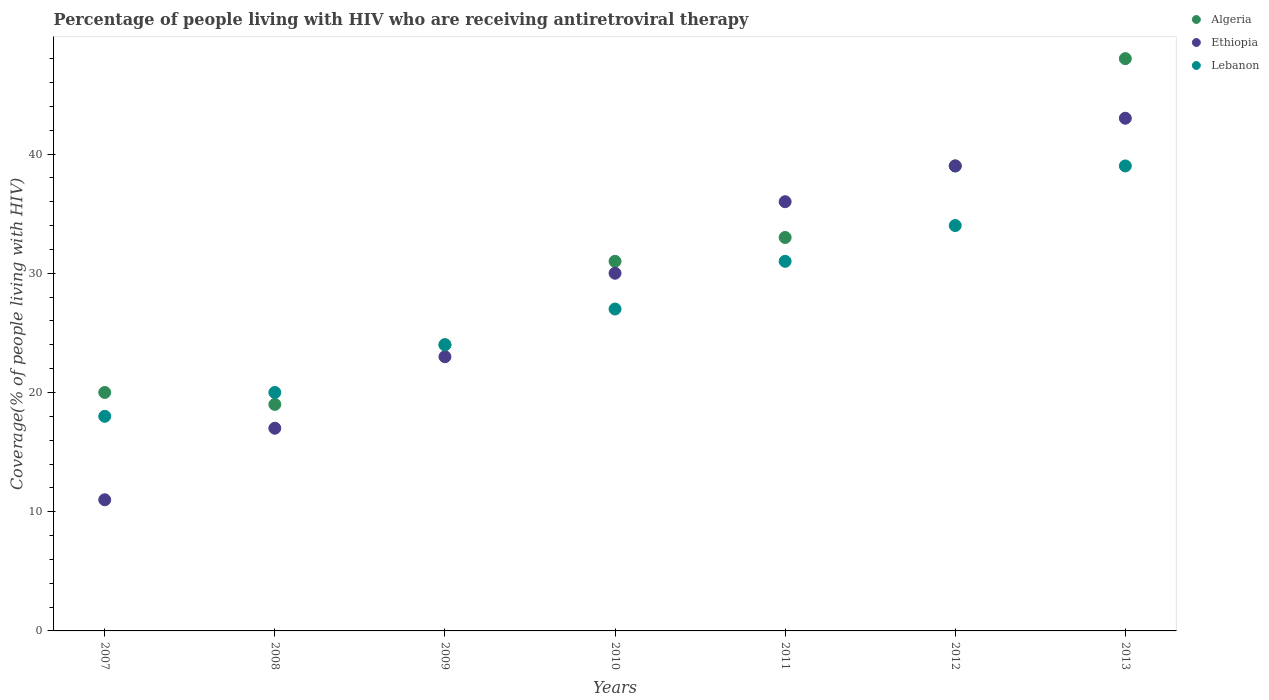How many different coloured dotlines are there?
Your answer should be very brief. 3. Is the number of dotlines equal to the number of legend labels?
Give a very brief answer. Yes. What is the percentage of the HIV infected people who are receiving antiretroviral therapy in Ethiopia in 2009?
Give a very brief answer. 23. Across all years, what is the maximum percentage of the HIV infected people who are receiving antiretroviral therapy in Lebanon?
Your answer should be compact. 39. Across all years, what is the minimum percentage of the HIV infected people who are receiving antiretroviral therapy in Ethiopia?
Ensure brevity in your answer.  11. In which year was the percentage of the HIV infected people who are receiving antiretroviral therapy in Lebanon maximum?
Ensure brevity in your answer.  2013. In which year was the percentage of the HIV infected people who are receiving antiretroviral therapy in Ethiopia minimum?
Make the answer very short. 2007. What is the total percentage of the HIV infected people who are receiving antiretroviral therapy in Algeria in the graph?
Provide a short and direct response. 214. What is the difference between the percentage of the HIV infected people who are receiving antiretroviral therapy in Ethiopia in 2009 and that in 2013?
Provide a short and direct response. -20. What is the difference between the percentage of the HIV infected people who are receiving antiretroviral therapy in Lebanon in 2011 and the percentage of the HIV infected people who are receiving antiretroviral therapy in Ethiopia in 2007?
Provide a short and direct response. 20. What is the average percentage of the HIV infected people who are receiving antiretroviral therapy in Algeria per year?
Your answer should be compact. 30.57. In the year 2010, what is the difference between the percentage of the HIV infected people who are receiving antiretroviral therapy in Lebanon and percentage of the HIV infected people who are receiving antiretroviral therapy in Algeria?
Provide a short and direct response. -4. In how many years, is the percentage of the HIV infected people who are receiving antiretroviral therapy in Ethiopia greater than 28 %?
Give a very brief answer. 4. What is the ratio of the percentage of the HIV infected people who are receiving antiretroviral therapy in Lebanon in 2008 to that in 2013?
Provide a succinct answer. 0.51. Is the percentage of the HIV infected people who are receiving antiretroviral therapy in Lebanon in 2009 less than that in 2011?
Ensure brevity in your answer.  Yes. What is the difference between the highest and the lowest percentage of the HIV infected people who are receiving antiretroviral therapy in Ethiopia?
Offer a terse response. 32. Does the percentage of the HIV infected people who are receiving antiretroviral therapy in Lebanon monotonically increase over the years?
Ensure brevity in your answer.  Yes. How many dotlines are there?
Your answer should be compact. 3. Does the graph contain any zero values?
Offer a very short reply. No. Does the graph contain grids?
Provide a succinct answer. No. Where does the legend appear in the graph?
Ensure brevity in your answer.  Top right. What is the title of the graph?
Your answer should be compact. Percentage of people living with HIV who are receiving antiretroviral therapy. Does "Netherlands" appear as one of the legend labels in the graph?
Make the answer very short. No. What is the label or title of the Y-axis?
Offer a very short reply. Coverage(% of people living with HIV). What is the Coverage(% of people living with HIV) in Algeria in 2008?
Ensure brevity in your answer.  19. What is the Coverage(% of people living with HIV) in Ethiopia in 2009?
Give a very brief answer. 23. What is the Coverage(% of people living with HIV) in Lebanon in 2009?
Ensure brevity in your answer.  24. What is the Coverage(% of people living with HIV) in Algeria in 2010?
Provide a succinct answer. 31. What is the Coverage(% of people living with HIV) in Lebanon in 2010?
Give a very brief answer. 27. What is the Coverage(% of people living with HIV) in Algeria in 2011?
Your response must be concise. 33. What is the Coverage(% of people living with HIV) of Ethiopia in 2011?
Provide a short and direct response. 36. What is the Coverage(% of people living with HIV) of Ethiopia in 2012?
Give a very brief answer. 39. What is the Coverage(% of people living with HIV) in Lebanon in 2012?
Keep it short and to the point. 34. What is the Coverage(% of people living with HIV) of Ethiopia in 2013?
Offer a very short reply. 43. What is the Coverage(% of people living with HIV) of Lebanon in 2013?
Make the answer very short. 39. Across all years, what is the maximum Coverage(% of people living with HIV) in Ethiopia?
Provide a short and direct response. 43. Across all years, what is the maximum Coverage(% of people living with HIV) in Lebanon?
Offer a terse response. 39. Across all years, what is the minimum Coverage(% of people living with HIV) of Algeria?
Ensure brevity in your answer.  19. Across all years, what is the minimum Coverage(% of people living with HIV) in Lebanon?
Give a very brief answer. 18. What is the total Coverage(% of people living with HIV) of Algeria in the graph?
Provide a short and direct response. 214. What is the total Coverage(% of people living with HIV) of Ethiopia in the graph?
Keep it short and to the point. 199. What is the total Coverage(% of people living with HIV) in Lebanon in the graph?
Provide a short and direct response. 193. What is the difference between the Coverage(% of people living with HIV) in Lebanon in 2007 and that in 2008?
Offer a very short reply. -2. What is the difference between the Coverage(% of people living with HIV) in Lebanon in 2007 and that in 2010?
Offer a terse response. -9. What is the difference between the Coverage(% of people living with HIV) in Algeria in 2007 and that in 2011?
Your answer should be compact. -13. What is the difference between the Coverage(% of people living with HIV) in Lebanon in 2007 and that in 2011?
Your answer should be compact. -13. What is the difference between the Coverage(% of people living with HIV) in Algeria in 2007 and that in 2012?
Offer a very short reply. -19. What is the difference between the Coverage(% of people living with HIV) in Ethiopia in 2007 and that in 2012?
Offer a very short reply. -28. What is the difference between the Coverage(% of people living with HIV) in Ethiopia in 2007 and that in 2013?
Your answer should be very brief. -32. What is the difference between the Coverage(% of people living with HIV) in Algeria in 2008 and that in 2009?
Ensure brevity in your answer.  -5. What is the difference between the Coverage(% of people living with HIV) in Lebanon in 2008 and that in 2009?
Give a very brief answer. -4. What is the difference between the Coverage(% of people living with HIV) in Algeria in 2008 and that in 2010?
Offer a very short reply. -12. What is the difference between the Coverage(% of people living with HIV) of Lebanon in 2008 and that in 2010?
Your answer should be very brief. -7. What is the difference between the Coverage(% of people living with HIV) in Ethiopia in 2008 and that in 2011?
Offer a very short reply. -19. What is the difference between the Coverage(% of people living with HIV) of Algeria in 2008 and that in 2012?
Offer a very short reply. -20. What is the difference between the Coverage(% of people living with HIV) of Lebanon in 2008 and that in 2012?
Give a very brief answer. -14. What is the difference between the Coverage(% of people living with HIV) of Ethiopia in 2008 and that in 2013?
Your answer should be very brief. -26. What is the difference between the Coverage(% of people living with HIV) of Algeria in 2009 and that in 2010?
Make the answer very short. -7. What is the difference between the Coverage(% of people living with HIV) in Algeria in 2009 and that in 2011?
Offer a very short reply. -9. What is the difference between the Coverage(% of people living with HIV) of Lebanon in 2009 and that in 2011?
Your answer should be compact. -7. What is the difference between the Coverage(% of people living with HIV) in Algeria in 2009 and that in 2012?
Your answer should be compact. -15. What is the difference between the Coverage(% of people living with HIV) in Ethiopia in 2009 and that in 2012?
Offer a terse response. -16. What is the difference between the Coverage(% of people living with HIV) in Ethiopia in 2009 and that in 2013?
Your answer should be very brief. -20. What is the difference between the Coverage(% of people living with HIV) in Ethiopia in 2010 and that in 2011?
Provide a succinct answer. -6. What is the difference between the Coverage(% of people living with HIV) in Algeria in 2010 and that in 2012?
Ensure brevity in your answer.  -8. What is the difference between the Coverage(% of people living with HIV) in Ethiopia in 2010 and that in 2012?
Your answer should be compact. -9. What is the difference between the Coverage(% of people living with HIV) in Algeria in 2010 and that in 2013?
Offer a terse response. -17. What is the difference between the Coverage(% of people living with HIV) in Lebanon in 2010 and that in 2013?
Your response must be concise. -12. What is the difference between the Coverage(% of people living with HIV) of Ethiopia in 2011 and that in 2012?
Your response must be concise. -3. What is the difference between the Coverage(% of people living with HIV) of Lebanon in 2011 and that in 2012?
Make the answer very short. -3. What is the difference between the Coverage(% of people living with HIV) in Lebanon in 2012 and that in 2013?
Ensure brevity in your answer.  -5. What is the difference between the Coverage(% of people living with HIV) of Algeria in 2007 and the Coverage(% of people living with HIV) of Lebanon in 2009?
Provide a short and direct response. -4. What is the difference between the Coverage(% of people living with HIV) of Ethiopia in 2007 and the Coverage(% of people living with HIV) of Lebanon in 2009?
Provide a succinct answer. -13. What is the difference between the Coverage(% of people living with HIV) of Algeria in 2007 and the Coverage(% of people living with HIV) of Lebanon in 2011?
Make the answer very short. -11. What is the difference between the Coverage(% of people living with HIV) in Ethiopia in 2007 and the Coverage(% of people living with HIV) in Lebanon in 2011?
Offer a very short reply. -20. What is the difference between the Coverage(% of people living with HIV) of Ethiopia in 2007 and the Coverage(% of people living with HIV) of Lebanon in 2012?
Offer a very short reply. -23. What is the difference between the Coverage(% of people living with HIV) of Algeria in 2007 and the Coverage(% of people living with HIV) of Ethiopia in 2013?
Your response must be concise. -23. What is the difference between the Coverage(% of people living with HIV) of Algeria in 2008 and the Coverage(% of people living with HIV) of Ethiopia in 2009?
Your answer should be very brief. -4. What is the difference between the Coverage(% of people living with HIV) of Algeria in 2008 and the Coverage(% of people living with HIV) of Ethiopia in 2011?
Your answer should be very brief. -17. What is the difference between the Coverage(% of people living with HIV) of Ethiopia in 2008 and the Coverage(% of people living with HIV) of Lebanon in 2012?
Your answer should be compact. -17. What is the difference between the Coverage(% of people living with HIV) of Ethiopia in 2009 and the Coverage(% of people living with HIV) of Lebanon in 2010?
Keep it short and to the point. -4. What is the difference between the Coverage(% of people living with HIV) in Algeria in 2009 and the Coverage(% of people living with HIV) in Ethiopia in 2011?
Provide a succinct answer. -12. What is the difference between the Coverage(% of people living with HIV) of Algeria in 2009 and the Coverage(% of people living with HIV) of Lebanon in 2011?
Ensure brevity in your answer.  -7. What is the difference between the Coverage(% of people living with HIV) of Algeria in 2009 and the Coverage(% of people living with HIV) of Lebanon in 2012?
Give a very brief answer. -10. What is the difference between the Coverage(% of people living with HIV) of Algeria in 2009 and the Coverage(% of people living with HIV) of Lebanon in 2013?
Offer a very short reply. -15. What is the difference between the Coverage(% of people living with HIV) of Algeria in 2010 and the Coverage(% of people living with HIV) of Ethiopia in 2011?
Provide a succinct answer. -5. What is the difference between the Coverage(% of people living with HIV) of Algeria in 2010 and the Coverage(% of people living with HIV) of Lebanon in 2011?
Your answer should be compact. 0. What is the difference between the Coverage(% of people living with HIV) in Algeria in 2010 and the Coverage(% of people living with HIV) in Lebanon in 2012?
Offer a terse response. -3. What is the difference between the Coverage(% of people living with HIV) of Algeria in 2011 and the Coverage(% of people living with HIV) of Lebanon in 2013?
Offer a terse response. -6. What is the difference between the Coverage(% of people living with HIV) of Ethiopia in 2011 and the Coverage(% of people living with HIV) of Lebanon in 2013?
Your response must be concise. -3. What is the difference between the Coverage(% of people living with HIV) of Algeria in 2012 and the Coverage(% of people living with HIV) of Ethiopia in 2013?
Offer a very short reply. -4. What is the average Coverage(% of people living with HIV) of Algeria per year?
Make the answer very short. 30.57. What is the average Coverage(% of people living with HIV) in Ethiopia per year?
Offer a very short reply. 28.43. What is the average Coverage(% of people living with HIV) in Lebanon per year?
Keep it short and to the point. 27.57. In the year 2008, what is the difference between the Coverage(% of people living with HIV) of Algeria and Coverage(% of people living with HIV) of Lebanon?
Your answer should be compact. -1. In the year 2009, what is the difference between the Coverage(% of people living with HIV) in Algeria and Coverage(% of people living with HIV) in Ethiopia?
Provide a short and direct response. 1. In the year 2009, what is the difference between the Coverage(% of people living with HIV) in Ethiopia and Coverage(% of people living with HIV) in Lebanon?
Offer a terse response. -1. In the year 2010, what is the difference between the Coverage(% of people living with HIV) in Algeria and Coverage(% of people living with HIV) in Ethiopia?
Provide a succinct answer. 1. In the year 2010, what is the difference between the Coverage(% of people living with HIV) in Algeria and Coverage(% of people living with HIV) in Lebanon?
Make the answer very short. 4. In the year 2010, what is the difference between the Coverage(% of people living with HIV) in Ethiopia and Coverage(% of people living with HIV) in Lebanon?
Keep it short and to the point. 3. In the year 2011, what is the difference between the Coverage(% of people living with HIV) in Algeria and Coverage(% of people living with HIV) in Lebanon?
Provide a short and direct response. 2. In the year 2011, what is the difference between the Coverage(% of people living with HIV) in Ethiopia and Coverage(% of people living with HIV) in Lebanon?
Offer a terse response. 5. In the year 2012, what is the difference between the Coverage(% of people living with HIV) of Algeria and Coverage(% of people living with HIV) of Ethiopia?
Offer a very short reply. 0. In the year 2013, what is the difference between the Coverage(% of people living with HIV) in Algeria and Coverage(% of people living with HIV) in Lebanon?
Your answer should be very brief. 9. In the year 2013, what is the difference between the Coverage(% of people living with HIV) of Ethiopia and Coverage(% of people living with HIV) of Lebanon?
Make the answer very short. 4. What is the ratio of the Coverage(% of people living with HIV) of Algeria in 2007 to that in 2008?
Offer a very short reply. 1.05. What is the ratio of the Coverage(% of people living with HIV) in Ethiopia in 2007 to that in 2008?
Your response must be concise. 0.65. What is the ratio of the Coverage(% of people living with HIV) of Algeria in 2007 to that in 2009?
Keep it short and to the point. 0.83. What is the ratio of the Coverage(% of people living with HIV) of Ethiopia in 2007 to that in 2009?
Provide a succinct answer. 0.48. What is the ratio of the Coverage(% of people living with HIV) in Lebanon in 2007 to that in 2009?
Ensure brevity in your answer.  0.75. What is the ratio of the Coverage(% of people living with HIV) in Algeria in 2007 to that in 2010?
Make the answer very short. 0.65. What is the ratio of the Coverage(% of people living with HIV) of Ethiopia in 2007 to that in 2010?
Make the answer very short. 0.37. What is the ratio of the Coverage(% of people living with HIV) in Lebanon in 2007 to that in 2010?
Your answer should be very brief. 0.67. What is the ratio of the Coverage(% of people living with HIV) of Algeria in 2007 to that in 2011?
Ensure brevity in your answer.  0.61. What is the ratio of the Coverage(% of people living with HIV) in Ethiopia in 2007 to that in 2011?
Offer a terse response. 0.31. What is the ratio of the Coverage(% of people living with HIV) of Lebanon in 2007 to that in 2011?
Provide a succinct answer. 0.58. What is the ratio of the Coverage(% of people living with HIV) in Algeria in 2007 to that in 2012?
Give a very brief answer. 0.51. What is the ratio of the Coverage(% of people living with HIV) of Ethiopia in 2007 to that in 2012?
Ensure brevity in your answer.  0.28. What is the ratio of the Coverage(% of people living with HIV) of Lebanon in 2007 to that in 2012?
Make the answer very short. 0.53. What is the ratio of the Coverage(% of people living with HIV) in Algeria in 2007 to that in 2013?
Keep it short and to the point. 0.42. What is the ratio of the Coverage(% of people living with HIV) in Ethiopia in 2007 to that in 2013?
Offer a very short reply. 0.26. What is the ratio of the Coverage(% of people living with HIV) of Lebanon in 2007 to that in 2013?
Provide a short and direct response. 0.46. What is the ratio of the Coverage(% of people living with HIV) of Algeria in 2008 to that in 2009?
Keep it short and to the point. 0.79. What is the ratio of the Coverage(% of people living with HIV) of Ethiopia in 2008 to that in 2009?
Your response must be concise. 0.74. What is the ratio of the Coverage(% of people living with HIV) of Algeria in 2008 to that in 2010?
Your answer should be very brief. 0.61. What is the ratio of the Coverage(% of people living with HIV) of Ethiopia in 2008 to that in 2010?
Provide a succinct answer. 0.57. What is the ratio of the Coverage(% of people living with HIV) in Lebanon in 2008 to that in 2010?
Offer a terse response. 0.74. What is the ratio of the Coverage(% of people living with HIV) in Algeria in 2008 to that in 2011?
Provide a short and direct response. 0.58. What is the ratio of the Coverage(% of people living with HIV) of Ethiopia in 2008 to that in 2011?
Offer a very short reply. 0.47. What is the ratio of the Coverage(% of people living with HIV) in Lebanon in 2008 to that in 2011?
Provide a succinct answer. 0.65. What is the ratio of the Coverage(% of people living with HIV) in Algeria in 2008 to that in 2012?
Make the answer very short. 0.49. What is the ratio of the Coverage(% of people living with HIV) in Ethiopia in 2008 to that in 2012?
Keep it short and to the point. 0.44. What is the ratio of the Coverage(% of people living with HIV) in Lebanon in 2008 to that in 2012?
Provide a short and direct response. 0.59. What is the ratio of the Coverage(% of people living with HIV) of Algeria in 2008 to that in 2013?
Keep it short and to the point. 0.4. What is the ratio of the Coverage(% of people living with HIV) in Ethiopia in 2008 to that in 2013?
Offer a very short reply. 0.4. What is the ratio of the Coverage(% of people living with HIV) of Lebanon in 2008 to that in 2013?
Provide a succinct answer. 0.51. What is the ratio of the Coverage(% of people living with HIV) in Algeria in 2009 to that in 2010?
Provide a succinct answer. 0.77. What is the ratio of the Coverage(% of people living with HIV) of Ethiopia in 2009 to that in 2010?
Make the answer very short. 0.77. What is the ratio of the Coverage(% of people living with HIV) in Lebanon in 2009 to that in 2010?
Your response must be concise. 0.89. What is the ratio of the Coverage(% of people living with HIV) of Algeria in 2009 to that in 2011?
Ensure brevity in your answer.  0.73. What is the ratio of the Coverage(% of people living with HIV) in Ethiopia in 2009 to that in 2011?
Ensure brevity in your answer.  0.64. What is the ratio of the Coverage(% of people living with HIV) in Lebanon in 2009 to that in 2011?
Your answer should be compact. 0.77. What is the ratio of the Coverage(% of people living with HIV) in Algeria in 2009 to that in 2012?
Make the answer very short. 0.62. What is the ratio of the Coverage(% of people living with HIV) in Ethiopia in 2009 to that in 2012?
Keep it short and to the point. 0.59. What is the ratio of the Coverage(% of people living with HIV) in Lebanon in 2009 to that in 2012?
Provide a short and direct response. 0.71. What is the ratio of the Coverage(% of people living with HIV) of Algeria in 2009 to that in 2013?
Offer a terse response. 0.5. What is the ratio of the Coverage(% of people living with HIV) of Ethiopia in 2009 to that in 2013?
Ensure brevity in your answer.  0.53. What is the ratio of the Coverage(% of people living with HIV) in Lebanon in 2009 to that in 2013?
Provide a short and direct response. 0.62. What is the ratio of the Coverage(% of people living with HIV) in Algeria in 2010 to that in 2011?
Provide a short and direct response. 0.94. What is the ratio of the Coverage(% of people living with HIV) in Lebanon in 2010 to that in 2011?
Give a very brief answer. 0.87. What is the ratio of the Coverage(% of people living with HIV) in Algeria in 2010 to that in 2012?
Offer a very short reply. 0.79. What is the ratio of the Coverage(% of people living with HIV) in Ethiopia in 2010 to that in 2012?
Your response must be concise. 0.77. What is the ratio of the Coverage(% of people living with HIV) of Lebanon in 2010 to that in 2012?
Your answer should be compact. 0.79. What is the ratio of the Coverage(% of people living with HIV) of Algeria in 2010 to that in 2013?
Ensure brevity in your answer.  0.65. What is the ratio of the Coverage(% of people living with HIV) of Ethiopia in 2010 to that in 2013?
Offer a terse response. 0.7. What is the ratio of the Coverage(% of people living with HIV) of Lebanon in 2010 to that in 2013?
Provide a short and direct response. 0.69. What is the ratio of the Coverage(% of people living with HIV) in Algeria in 2011 to that in 2012?
Your response must be concise. 0.85. What is the ratio of the Coverage(% of people living with HIV) in Ethiopia in 2011 to that in 2012?
Your answer should be very brief. 0.92. What is the ratio of the Coverage(% of people living with HIV) of Lebanon in 2011 to that in 2012?
Offer a terse response. 0.91. What is the ratio of the Coverage(% of people living with HIV) of Algeria in 2011 to that in 2013?
Provide a short and direct response. 0.69. What is the ratio of the Coverage(% of people living with HIV) of Ethiopia in 2011 to that in 2013?
Offer a very short reply. 0.84. What is the ratio of the Coverage(% of people living with HIV) of Lebanon in 2011 to that in 2013?
Make the answer very short. 0.79. What is the ratio of the Coverage(% of people living with HIV) in Algeria in 2012 to that in 2013?
Offer a very short reply. 0.81. What is the ratio of the Coverage(% of people living with HIV) of Ethiopia in 2012 to that in 2013?
Offer a terse response. 0.91. What is the ratio of the Coverage(% of people living with HIV) in Lebanon in 2012 to that in 2013?
Provide a succinct answer. 0.87. What is the difference between the highest and the second highest Coverage(% of people living with HIV) of Ethiopia?
Offer a very short reply. 4. What is the difference between the highest and the second highest Coverage(% of people living with HIV) of Lebanon?
Offer a very short reply. 5. What is the difference between the highest and the lowest Coverage(% of people living with HIV) of Algeria?
Provide a short and direct response. 29. What is the difference between the highest and the lowest Coverage(% of people living with HIV) in Ethiopia?
Your answer should be compact. 32. What is the difference between the highest and the lowest Coverage(% of people living with HIV) of Lebanon?
Give a very brief answer. 21. 